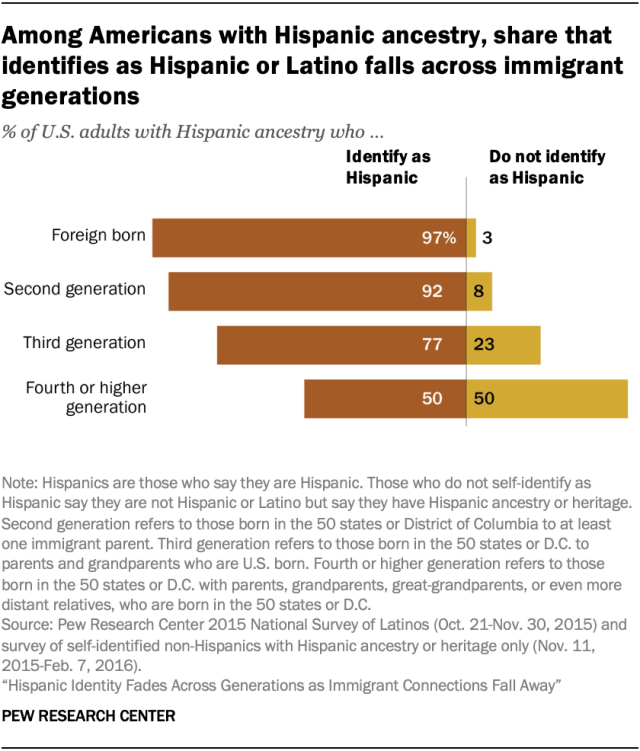Highlight a few significant elements in this photo. The yellow bar represents the Hispanic ethnicity, and I do not identify as Hispanic. The ratio between the two columns in fourth or higher generation is 0.042361111... 